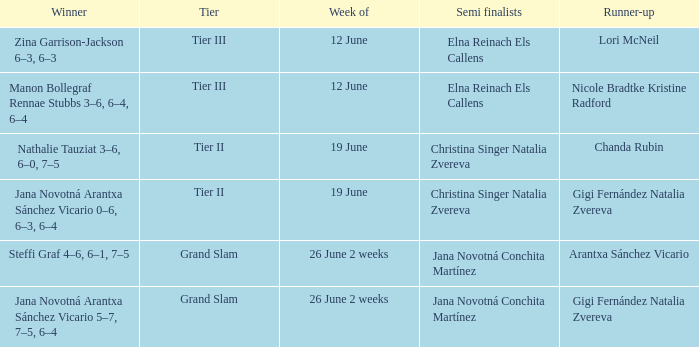In which week is the winner listed as Jana Novotná Arantxa Sánchez Vicario 5–7, 7–5, 6–4? 26 June 2 weeks. 